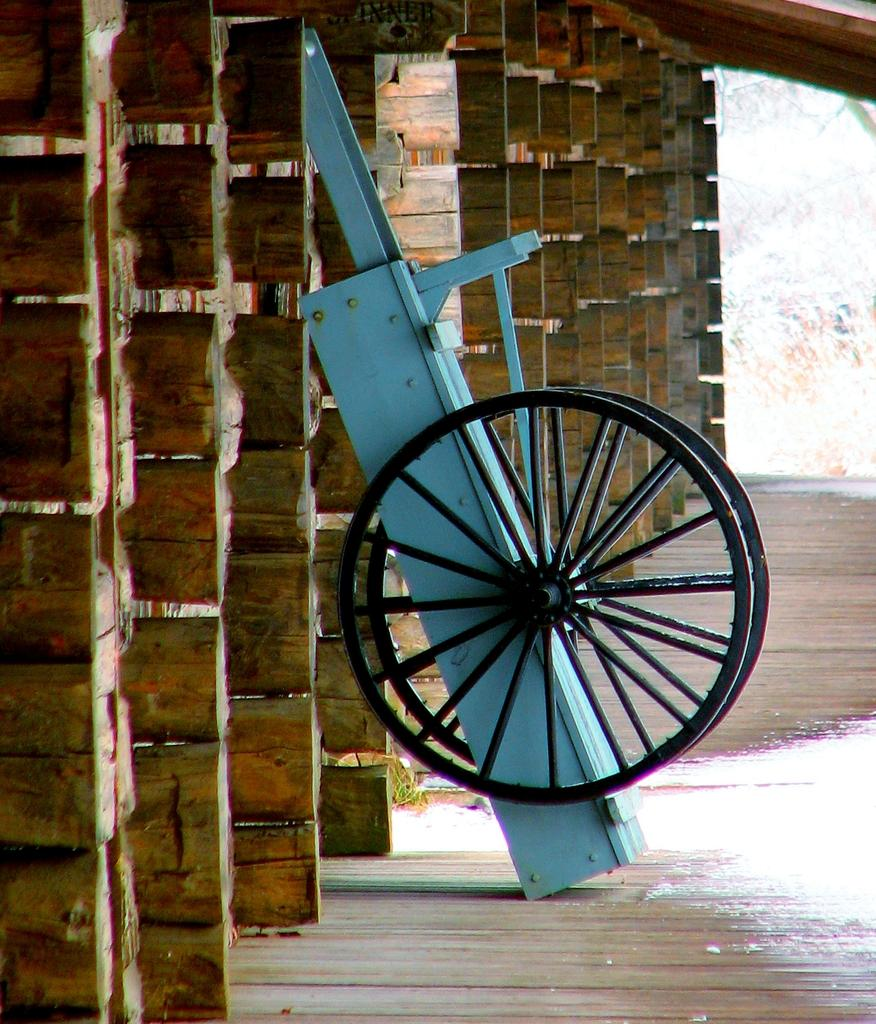What type of vehicle is in the image? There is a wheel cart in the image. What material is the floor made of? The floor is made of wood. What is the wall made of in the image? The wall is made of wood. How many sheep can be seen in the image? There are no sheep present in the image. What type of house is depicted in the image? The image does not show a house; it features a wheel cart and wooden floor and wall. 